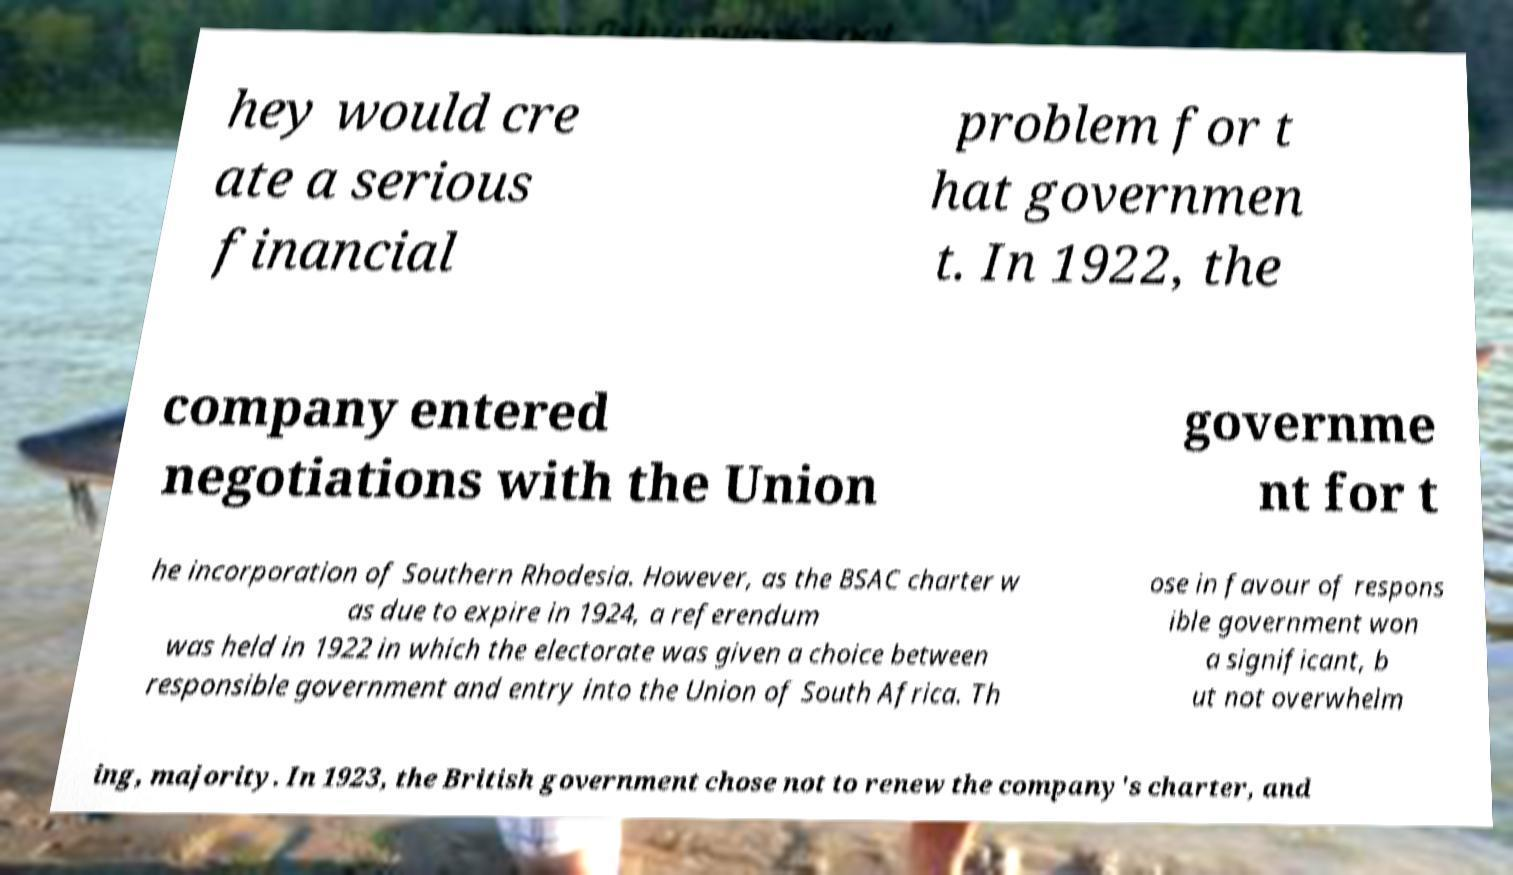Please read and relay the text visible in this image. What does it say? hey would cre ate a serious financial problem for t hat governmen t. In 1922, the company entered negotiations with the Union governme nt for t he incorporation of Southern Rhodesia. However, as the BSAC charter w as due to expire in 1924, a referendum was held in 1922 in which the electorate was given a choice between responsible government and entry into the Union of South Africa. Th ose in favour of respons ible government won a significant, b ut not overwhelm ing, majority. In 1923, the British government chose not to renew the company's charter, and 